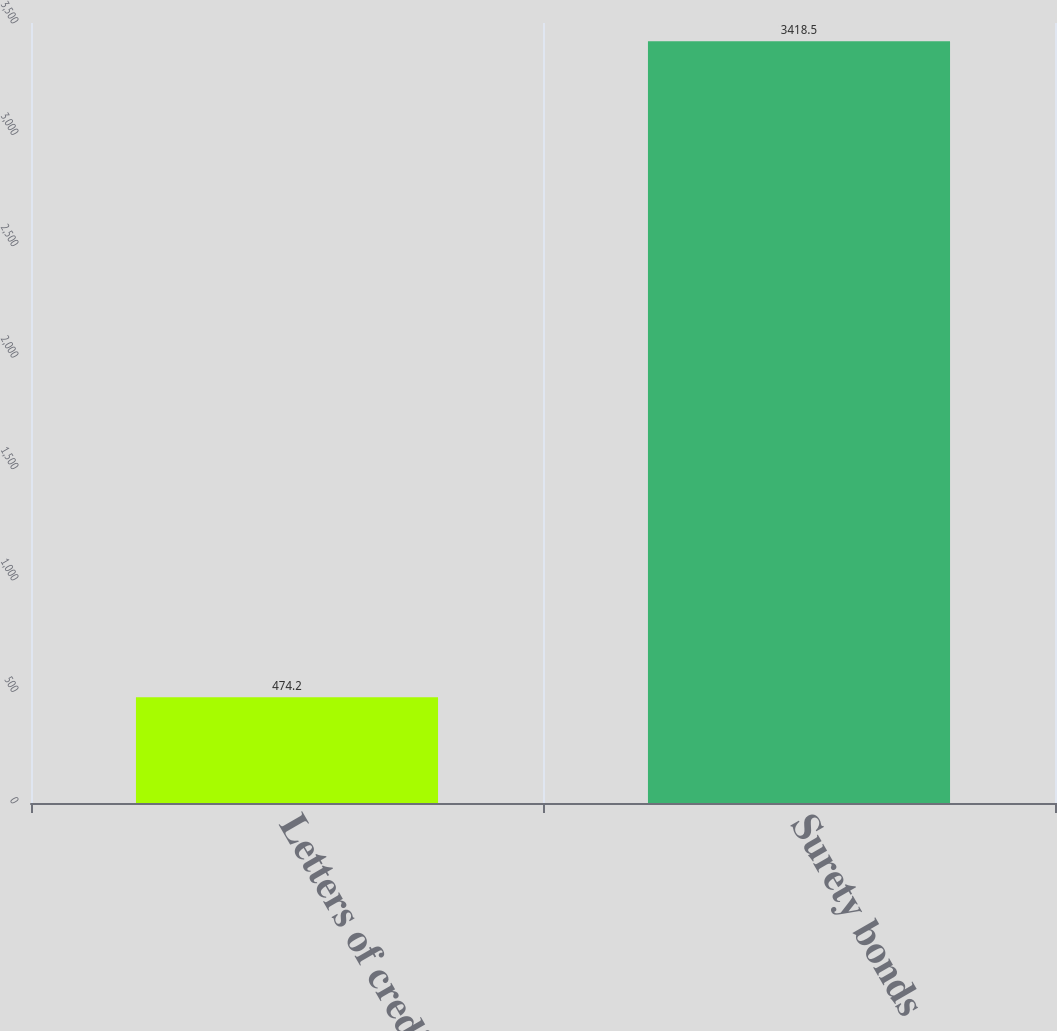<chart> <loc_0><loc_0><loc_500><loc_500><bar_chart><fcel>Letters of credit<fcel>Surety bonds<nl><fcel>474.2<fcel>3418.5<nl></chart> 